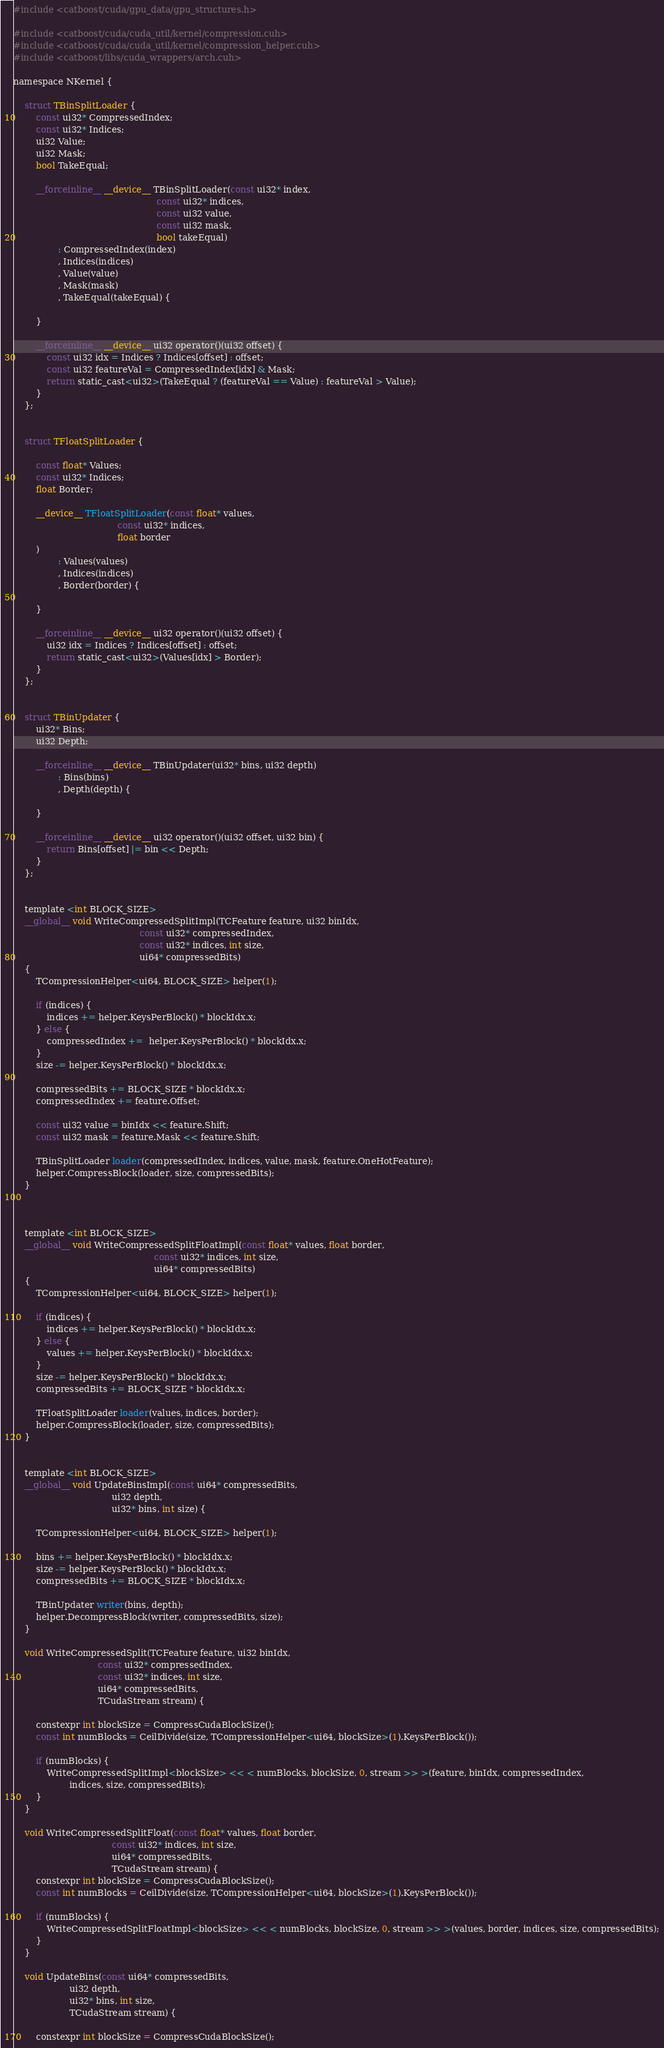Convert code to text. <code><loc_0><loc_0><loc_500><loc_500><_Cuda_>#include <catboost/cuda/gpu_data/gpu_structures.h>

#include <catboost/cuda/cuda_util/kernel/compression.cuh>
#include <catboost/cuda/cuda_util/kernel/compression_helper.cuh>
#include <catboost/libs/cuda_wrappers/arch.cuh>

namespace NKernel {

    struct TBinSplitLoader {
        const ui32* CompressedIndex;
        const ui32* Indices;
        ui32 Value;
        ui32 Mask;
        bool TakeEqual;

        __forceinline__ __device__ TBinSplitLoader(const ui32* index,
                                                   const ui32* indices,
                                                   const ui32 value,
                                                   const ui32 mask,
                                                   bool takeEqual)
                : CompressedIndex(index)
                , Indices(indices)
                , Value(value)
                , Mask(mask)
                , TakeEqual(takeEqual) {

        }

        __forceinline__ __device__ ui32 operator()(ui32 offset) {
            const ui32 idx = Indices ? Indices[offset] : offset;
            const ui32 featureVal = CompressedIndex[idx] & Mask;
            return static_cast<ui32>(TakeEqual ? (featureVal == Value) : featureVal > Value);
        }
    };


    struct TFloatSplitLoader {

        const float* Values;
        const ui32* Indices;
        float Border;

        __device__ TFloatSplitLoader(const float* values,
                                     const ui32* indices,
                                     float border
        )
                : Values(values)
                , Indices(indices)
                , Border(border) {

        }

        __forceinline__ __device__ ui32 operator()(ui32 offset) {
            ui32 idx = Indices ? Indices[offset] : offset;
            return static_cast<ui32>(Values[idx] > Border);
        }
    };


    struct TBinUpdater {
        ui32* Bins;
        ui32 Depth;

        __forceinline__ __device__ TBinUpdater(ui32* bins, ui32 depth)
                : Bins(bins)
                , Depth(depth) {

        }

        __forceinline__ __device__ ui32 operator()(ui32 offset, ui32 bin) {
            return Bins[offset] |= bin << Depth;
        }
    };


    template <int BLOCK_SIZE>
    __global__ void WriteCompressedSplitImpl(TCFeature feature, ui32 binIdx,
                                             const ui32* compressedIndex,
                                             const ui32* indices, int size,
                                             ui64* compressedBits)
    {
        TCompressionHelper<ui64, BLOCK_SIZE> helper(1);

        if (indices) {
            indices += helper.KeysPerBlock() * blockIdx.x;
        } else {
            compressedIndex +=  helper.KeysPerBlock() * blockIdx.x;
        }
        size -= helper.KeysPerBlock() * blockIdx.x;

        compressedBits += BLOCK_SIZE * blockIdx.x;
        compressedIndex += feature.Offset;

        const ui32 value = binIdx << feature.Shift;
        const ui32 mask = feature.Mask << feature.Shift;

        TBinSplitLoader loader(compressedIndex, indices, value, mask, feature.OneHotFeature);
        helper.CompressBlock(loader, size, compressedBits);
    }



    template <int BLOCK_SIZE>
    __global__ void WriteCompressedSplitFloatImpl(const float* values, float border,
                                                  const ui32* indices, int size,
                                                  ui64* compressedBits)
    {
        TCompressionHelper<ui64, BLOCK_SIZE> helper(1);

        if (indices) {
            indices += helper.KeysPerBlock() * blockIdx.x;
        } else {
            values += helper.KeysPerBlock() * blockIdx.x;
        }
        size -= helper.KeysPerBlock() * blockIdx.x;
        compressedBits += BLOCK_SIZE * blockIdx.x;

        TFloatSplitLoader loader(values, indices, border);
        helper.CompressBlock(loader, size, compressedBits);
    }


    template <int BLOCK_SIZE>
    __global__ void UpdateBinsImpl(const ui64* compressedBits,
                                   ui32 depth,
                                   ui32* bins, int size) {

        TCompressionHelper<ui64, BLOCK_SIZE> helper(1);

        bins += helper.KeysPerBlock() * blockIdx.x;
        size -= helper.KeysPerBlock() * blockIdx.x;
        compressedBits += BLOCK_SIZE * blockIdx.x;

        TBinUpdater writer(bins, depth);
        helper.DecompressBlock(writer, compressedBits, size);
    }

    void WriteCompressedSplit(TCFeature feature, ui32 binIdx,
                              const ui32* compressedIndex,
                              const ui32* indices, int size,
                              ui64* compressedBits,
                              TCudaStream stream) {

        constexpr int blockSize = CompressCudaBlockSize();
        const int numBlocks = CeilDivide(size, TCompressionHelper<ui64, blockSize>(1).KeysPerBlock());

        if (numBlocks) {
            WriteCompressedSplitImpl<blockSize> << < numBlocks, blockSize, 0, stream >> >(feature, binIdx, compressedIndex,
                    indices, size, compressedBits);
        }
    }

    void WriteCompressedSplitFloat(const float* values, float border,
                                   const ui32* indices, int size,
                                   ui64* compressedBits,
                                   TCudaStream stream) {
        constexpr int blockSize = CompressCudaBlockSize();
        const int numBlocks = CeilDivide(size, TCompressionHelper<ui64, blockSize>(1).KeysPerBlock());

        if (numBlocks) {
            WriteCompressedSplitFloatImpl<blockSize> << < numBlocks, blockSize, 0, stream >> >(values, border, indices, size, compressedBits);
        }
    }

    void UpdateBins(const ui64* compressedBits,
                    ui32 depth,
                    ui32* bins, int size,
                    TCudaStream stream) {

        constexpr int blockSize = CompressCudaBlockSize();</code> 